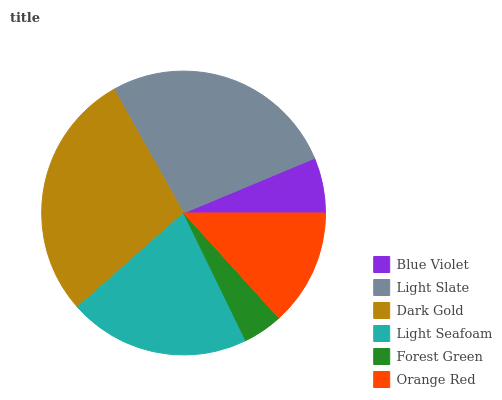Is Forest Green the minimum?
Answer yes or no. Yes. Is Dark Gold the maximum?
Answer yes or no. Yes. Is Light Slate the minimum?
Answer yes or no. No. Is Light Slate the maximum?
Answer yes or no. No. Is Light Slate greater than Blue Violet?
Answer yes or no. Yes. Is Blue Violet less than Light Slate?
Answer yes or no. Yes. Is Blue Violet greater than Light Slate?
Answer yes or no. No. Is Light Slate less than Blue Violet?
Answer yes or no. No. Is Light Seafoam the high median?
Answer yes or no. Yes. Is Orange Red the low median?
Answer yes or no. Yes. Is Light Slate the high median?
Answer yes or no. No. Is Forest Green the low median?
Answer yes or no. No. 